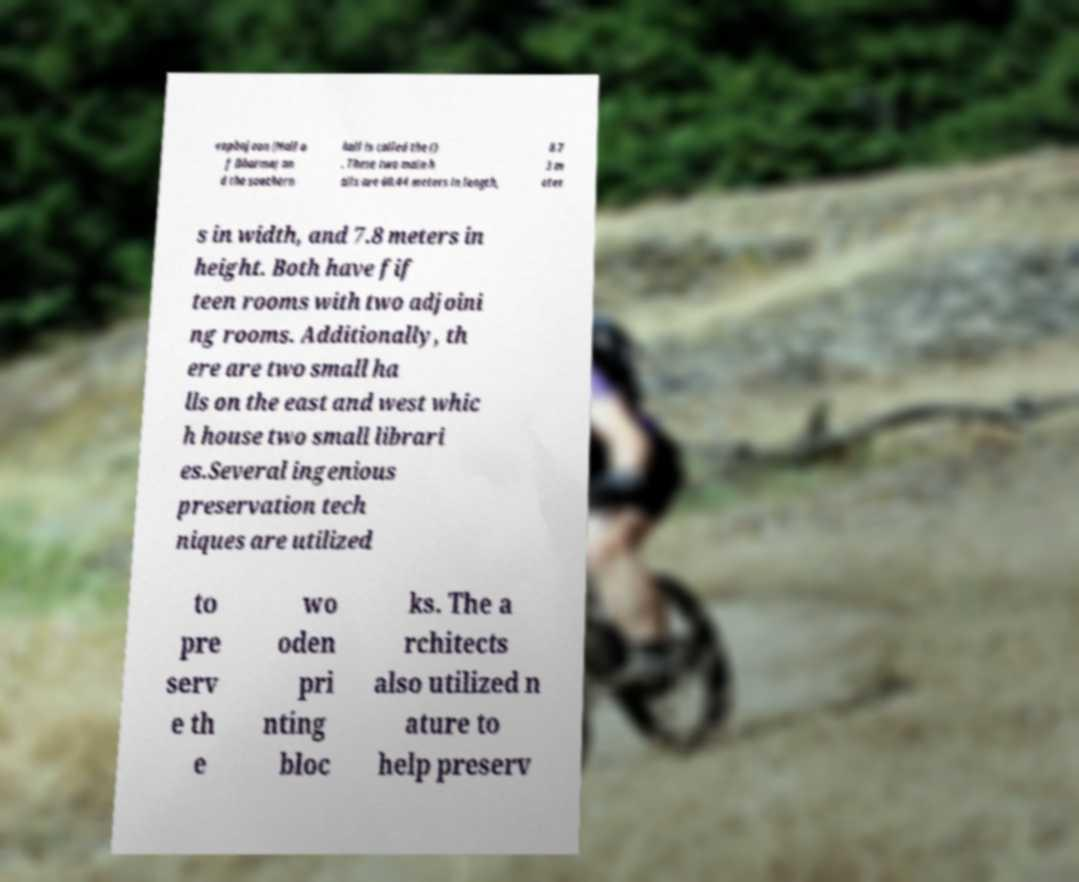Can you read and provide the text displayed in the image?This photo seems to have some interesting text. Can you extract and type it out for me? eopbojeon (Hall o f Dharma) an d the southern hall is called the () . These two main h alls are 60.44 meters in length, 8.7 3 m eter s in width, and 7.8 meters in height. Both have fif teen rooms with two adjoini ng rooms. Additionally, th ere are two small ha lls on the east and west whic h house two small librari es.Several ingenious preservation tech niques are utilized to pre serv e th e wo oden pri nting bloc ks. The a rchitects also utilized n ature to help preserv 